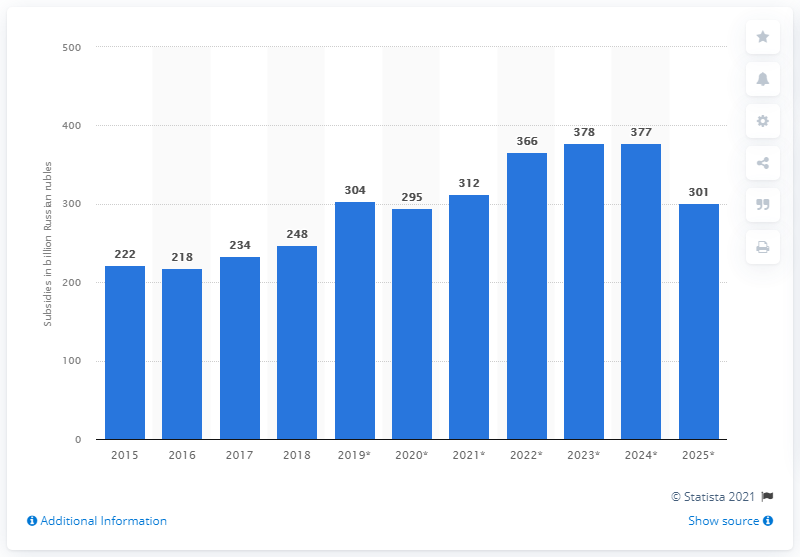Specify some key components in this picture. The expected amount of Russian rubles in agricultural subsidies for the year 2024 is 377. 